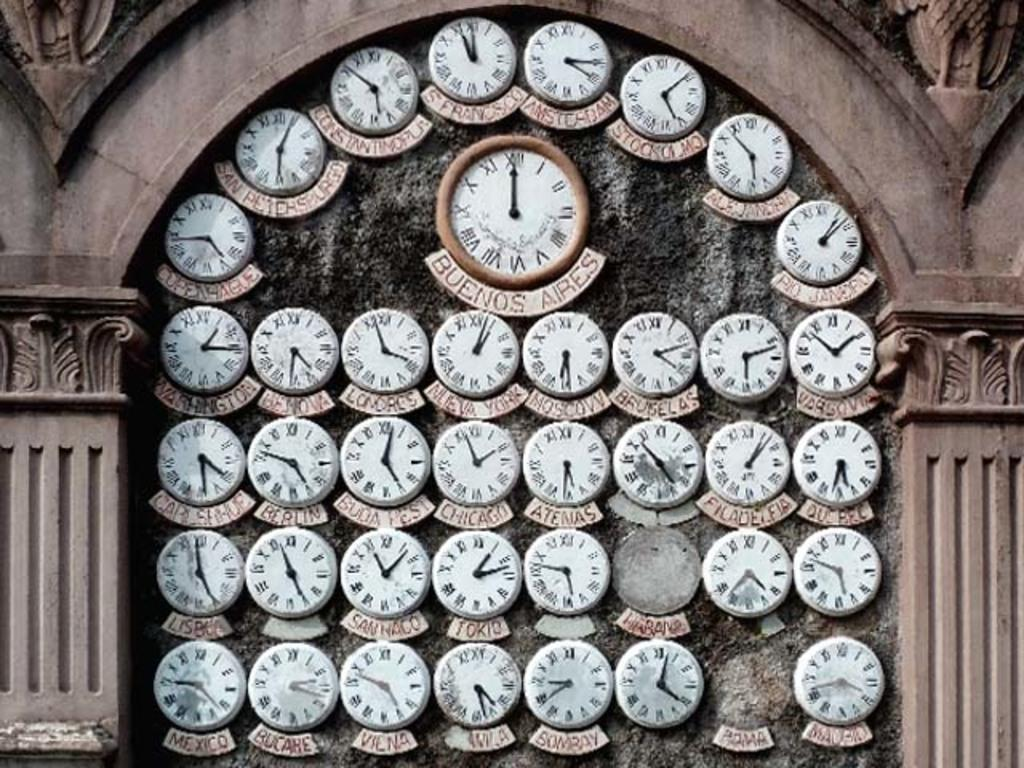Provide a one-sentence caption for the provided image. Small clocks showing the time in various cities surrounding a larger clock with the time in Buenos Aires. 